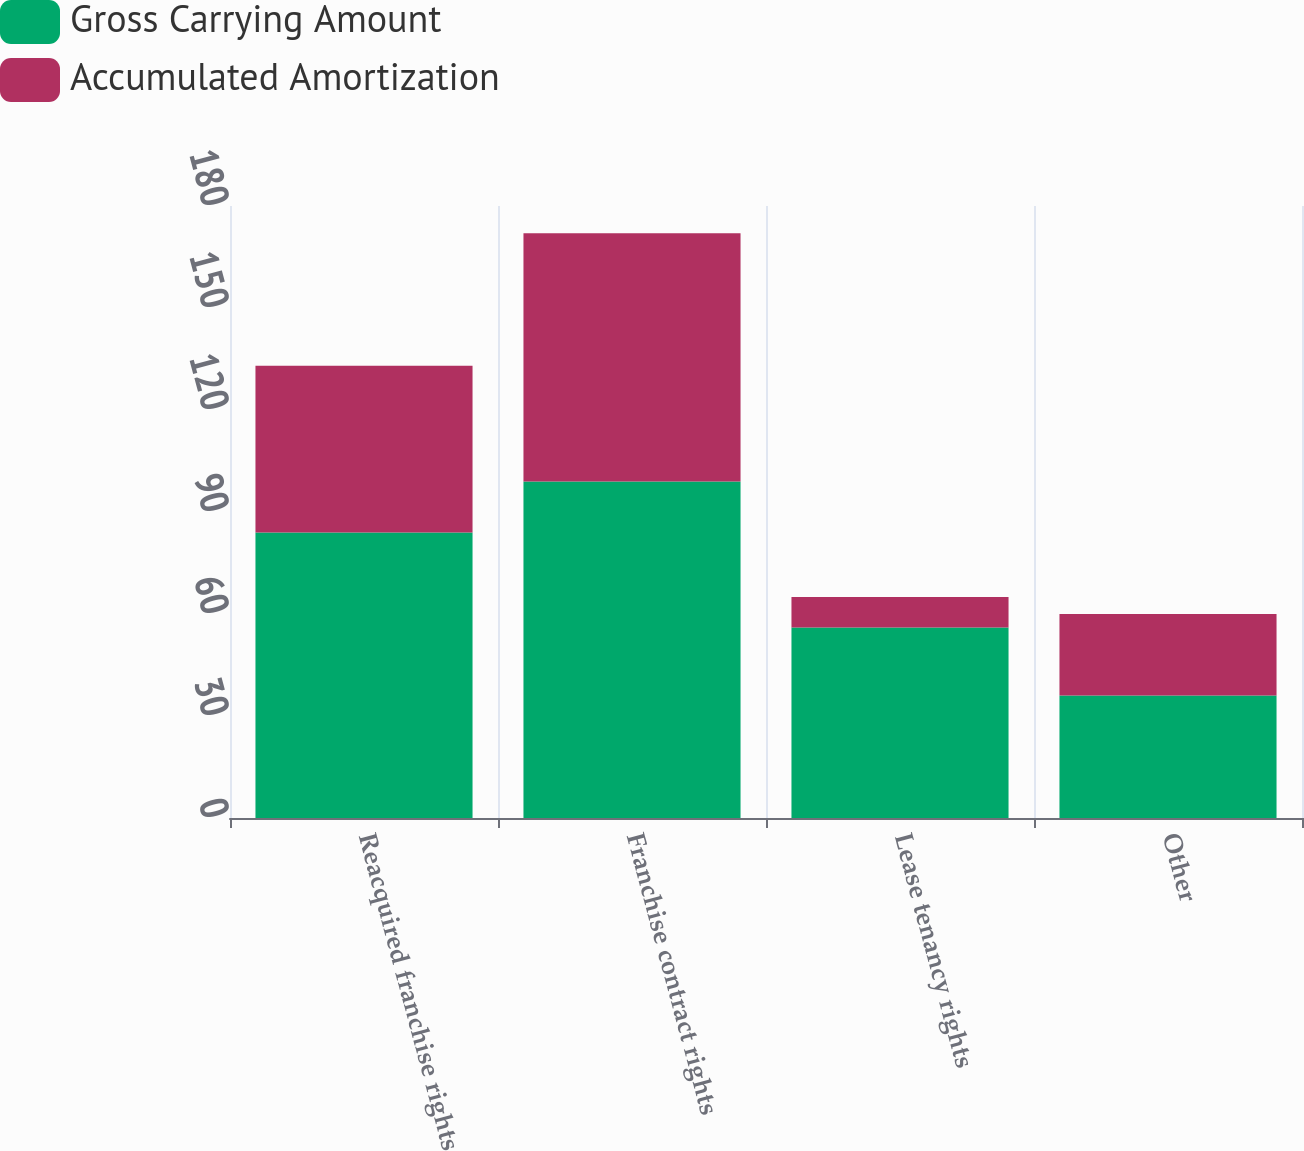Convert chart to OTSL. <chart><loc_0><loc_0><loc_500><loc_500><stacked_bar_chart><ecel><fcel>Reacquired franchise rights<fcel>Franchise contract rights<fcel>Lease tenancy rights<fcel>Other<nl><fcel>Gross Carrying Amount<fcel>84<fcel>99<fcel>56<fcel>36<nl><fcel>Accumulated Amortization<fcel>49<fcel>73<fcel>9<fcel>24<nl></chart> 